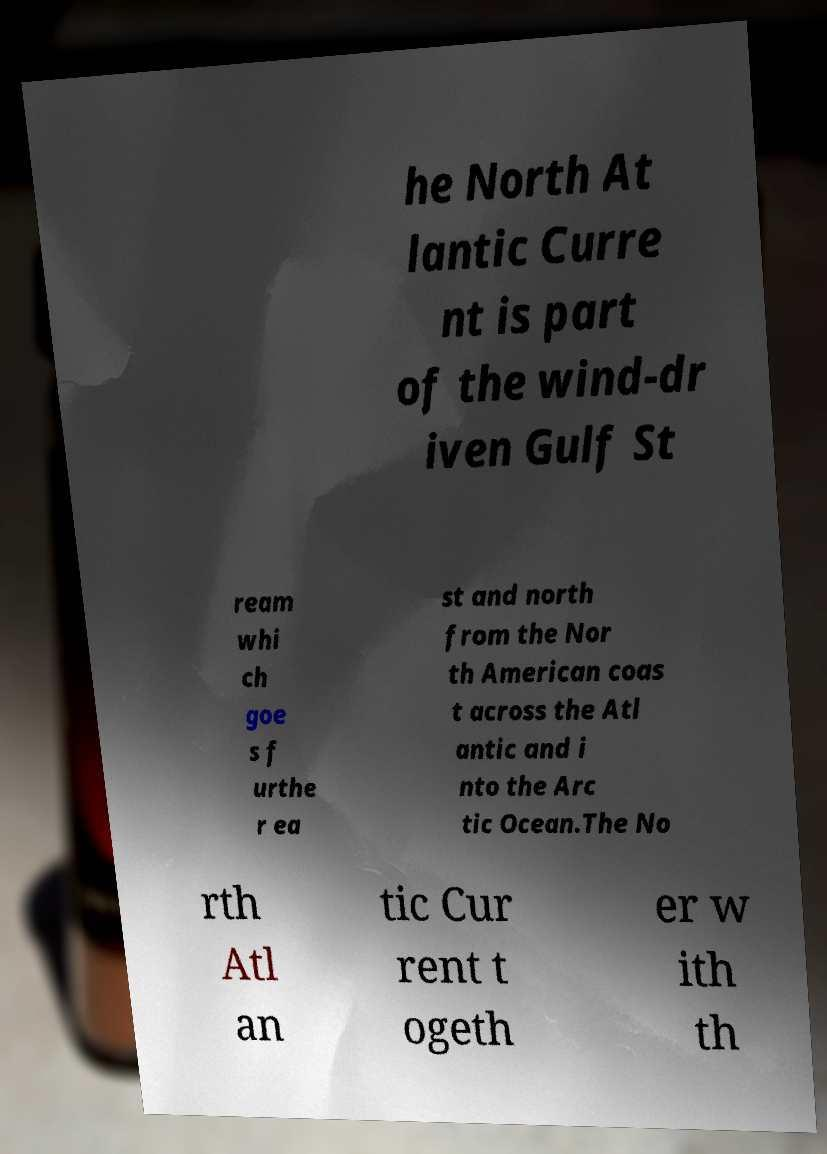Can you read and provide the text displayed in the image?This photo seems to have some interesting text. Can you extract and type it out for me? he North At lantic Curre nt is part of the wind-dr iven Gulf St ream whi ch goe s f urthe r ea st and north from the Nor th American coas t across the Atl antic and i nto the Arc tic Ocean.The No rth Atl an tic Cur rent t ogeth er w ith th 